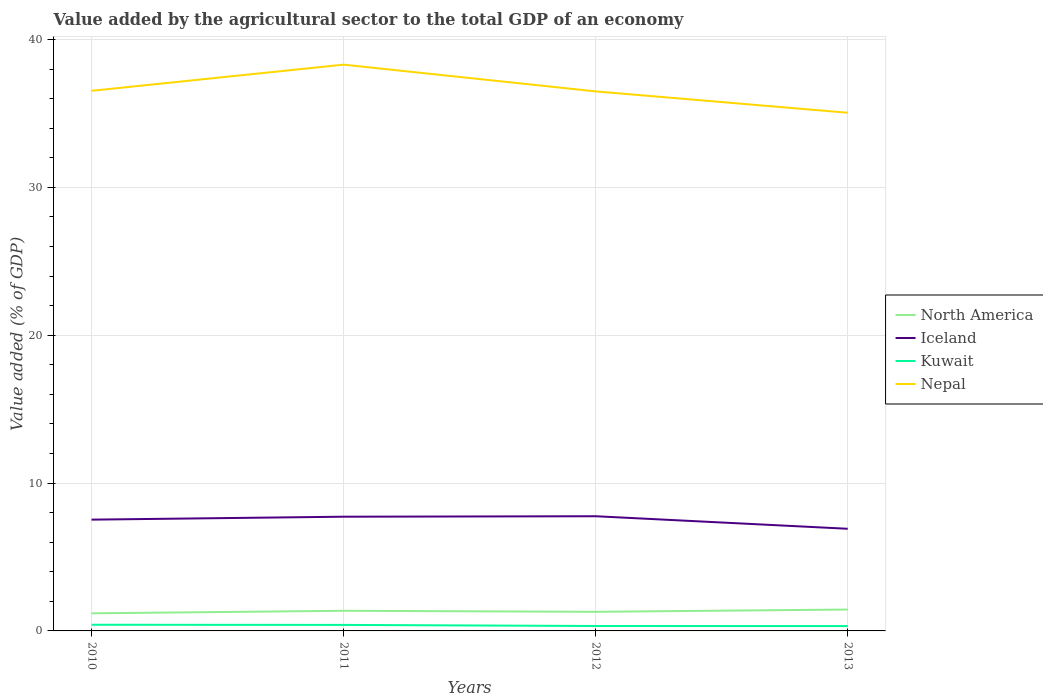How many different coloured lines are there?
Keep it short and to the point. 4. Does the line corresponding to Nepal intersect with the line corresponding to Kuwait?
Provide a short and direct response. No. Across all years, what is the maximum value added by the agricultural sector to the total GDP in North America?
Give a very brief answer. 1.19. What is the total value added by the agricultural sector to the total GDP in North America in the graph?
Provide a short and direct response. -0.08. What is the difference between the highest and the second highest value added by the agricultural sector to the total GDP in North America?
Offer a very short reply. 0.26. What is the difference between the highest and the lowest value added by the agricultural sector to the total GDP in North America?
Your answer should be very brief. 2. Is the value added by the agricultural sector to the total GDP in Nepal strictly greater than the value added by the agricultural sector to the total GDP in Iceland over the years?
Your answer should be very brief. No. How many lines are there?
Your answer should be compact. 4. What is the difference between two consecutive major ticks on the Y-axis?
Your response must be concise. 10. How are the legend labels stacked?
Provide a short and direct response. Vertical. What is the title of the graph?
Give a very brief answer. Value added by the agricultural sector to the total GDP of an economy. What is the label or title of the X-axis?
Your answer should be compact. Years. What is the label or title of the Y-axis?
Provide a short and direct response. Value added (% of GDP). What is the Value added (% of GDP) in North America in 2010?
Make the answer very short. 1.19. What is the Value added (% of GDP) of Iceland in 2010?
Your response must be concise. 7.53. What is the Value added (% of GDP) in Kuwait in 2010?
Ensure brevity in your answer.  0.42. What is the Value added (% of GDP) of Nepal in 2010?
Your response must be concise. 36.53. What is the Value added (% of GDP) of North America in 2011?
Keep it short and to the point. 1.36. What is the Value added (% of GDP) of Iceland in 2011?
Your answer should be very brief. 7.72. What is the Value added (% of GDP) in Kuwait in 2011?
Give a very brief answer. 0.41. What is the Value added (% of GDP) of Nepal in 2011?
Your answer should be compact. 38.3. What is the Value added (% of GDP) of North America in 2012?
Make the answer very short. 1.29. What is the Value added (% of GDP) in Iceland in 2012?
Provide a succinct answer. 7.76. What is the Value added (% of GDP) of Kuwait in 2012?
Your response must be concise. 0.33. What is the Value added (% of GDP) in Nepal in 2012?
Give a very brief answer. 36.49. What is the Value added (% of GDP) of North America in 2013?
Your response must be concise. 1.45. What is the Value added (% of GDP) in Iceland in 2013?
Your response must be concise. 6.91. What is the Value added (% of GDP) of Kuwait in 2013?
Make the answer very short. 0.33. What is the Value added (% of GDP) in Nepal in 2013?
Keep it short and to the point. 35.05. Across all years, what is the maximum Value added (% of GDP) of North America?
Your response must be concise. 1.45. Across all years, what is the maximum Value added (% of GDP) of Iceland?
Make the answer very short. 7.76. Across all years, what is the maximum Value added (% of GDP) of Kuwait?
Your response must be concise. 0.42. Across all years, what is the maximum Value added (% of GDP) of Nepal?
Offer a terse response. 38.3. Across all years, what is the minimum Value added (% of GDP) in North America?
Your response must be concise. 1.19. Across all years, what is the minimum Value added (% of GDP) in Iceland?
Keep it short and to the point. 6.91. Across all years, what is the minimum Value added (% of GDP) in Kuwait?
Offer a terse response. 0.33. Across all years, what is the minimum Value added (% of GDP) of Nepal?
Ensure brevity in your answer.  35.05. What is the total Value added (% of GDP) of North America in the graph?
Provide a succinct answer. 5.29. What is the total Value added (% of GDP) in Iceland in the graph?
Offer a very short reply. 29.91. What is the total Value added (% of GDP) in Kuwait in the graph?
Ensure brevity in your answer.  1.49. What is the total Value added (% of GDP) of Nepal in the graph?
Ensure brevity in your answer.  146.36. What is the difference between the Value added (% of GDP) in North America in 2010 and that in 2011?
Your answer should be very brief. -0.17. What is the difference between the Value added (% of GDP) of Iceland in 2010 and that in 2011?
Your answer should be very brief. -0.2. What is the difference between the Value added (% of GDP) in Kuwait in 2010 and that in 2011?
Your answer should be compact. 0.01. What is the difference between the Value added (% of GDP) in Nepal in 2010 and that in 2011?
Keep it short and to the point. -1.77. What is the difference between the Value added (% of GDP) in North America in 2010 and that in 2012?
Offer a terse response. -0.1. What is the difference between the Value added (% of GDP) of Iceland in 2010 and that in 2012?
Give a very brief answer. -0.23. What is the difference between the Value added (% of GDP) of Kuwait in 2010 and that in 2012?
Offer a very short reply. 0.09. What is the difference between the Value added (% of GDP) in Nepal in 2010 and that in 2012?
Provide a short and direct response. 0.04. What is the difference between the Value added (% of GDP) in North America in 2010 and that in 2013?
Your answer should be very brief. -0.26. What is the difference between the Value added (% of GDP) of Iceland in 2010 and that in 2013?
Offer a very short reply. 0.62. What is the difference between the Value added (% of GDP) of Kuwait in 2010 and that in 2013?
Your answer should be very brief. 0.09. What is the difference between the Value added (% of GDP) of Nepal in 2010 and that in 2013?
Offer a terse response. 1.48. What is the difference between the Value added (% of GDP) in North America in 2011 and that in 2012?
Offer a terse response. 0.07. What is the difference between the Value added (% of GDP) of Iceland in 2011 and that in 2012?
Make the answer very short. -0.03. What is the difference between the Value added (% of GDP) in Kuwait in 2011 and that in 2012?
Give a very brief answer. 0.07. What is the difference between the Value added (% of GDP) in Nepal in 2011 and that in 2012?
Ensure brevity in your answer.  1.81. What is the difference between the Value added (% of GDP) in North America in 2011 and that in 2013?
Make the answer very short. -0.08. What is the difference between the Value added (% of GDP) of Iceland in 2011 and that in 2013?
Ensure brevity in your answer.  0.82. What is the difference between the Value added (% of GDP) in Kuwait in 2011 and that in 2013?
Ensure brevity in your answer.  0.08. What is the difference between the Value added (% of GDP) in Nepal in 2011 and that in 2013?
Make the answer very short. 3.25. What is the difference between the Value added (% of GDP) of North America in 2012 and that in 2013?
Offer a terse response. -0.15. What is the difference between the Value added (% of GDP) of Iceland in 2012 and that in 2013?
Ensure brevity in your answer.  0.85. What is the difference between the Value added (% of GDP) in Kuwait in 2012 and that in 2013?
Your answer should be compact. 0. What is the difference between the Value added (% of GDP) of Nepal in 2012 and that in 2013?
Offer a terse response. 1.44. What is the difference between the Value added (% of GDP) of North America in 2010 and the Value added (% of GDP) of Iceland in 2011?
Provide a succinct answer. -6.53. What is the difference between the Value added (% of GDP) of North America in 2010 and the Value added (% of GDP) of Kuwait in 2011?
Provide a succinct answer. 0.78. What is the difference between the Value added (% of GDP) in North America in 2010 and the Value added (% of GDP) in Nepal in 2011?
Your response must be concise. -37.11. What is the difference between the Value added (% of GDP) in Iceland in 2010 and the Value added (% of GDP) in Kuwait in 2011?
Your response must be concise. 7.12. What is the difference between the Value added (% of GDP) of Iceland in 2010 and the Value added (% of GDP) of Nepal in 2011?
Your answer should be very brief. -30.77. What is the difference between the Value added (% of GDP) of Kuwait in 2010 and the Value added (% of GDP) of Nepal in 2011?
Give a very brief answer. -37.88. What is the difference between the Value added (% of GDP) in North America in 2010 and the Value added (% of GDP) in Iceland in 2012?
Give a very brief answer. -6.57. What is the difference between the Value added (% of GDP) in North America in 2010 and the Value added (% of GDP) in Kuwait in 2012?
Offer a very short reply. 0.86. What is the difference between the Value added (% of GDP) in North America in 2010 and the Value added (% of GDP) in Nepal in 2012?
Offer a very short reply. -35.3. What is the difference between the Value added (% of GDP) of Iceland in 2010 and the Value added (% of GDP) of Kuwait in 2012?
Offer a very short reply. 7.19. What is the difference between the Value added (% of GDP) of Iceland in 2010 and the Value added (% of GDP) of Nepal in 2012?
Your answer should be compact. -28.96. What is the difference between the Value added (% of GDP) in Kuwait in 2010 and the Value added (% of GDP) in Nepal in 2012?
Offer a very short reply. -36.07. What is the difference between the Value added (% of GDP) in North America in 2010 and the Value added (% of GDP) in Iceland in 2013?
Your answer should be very brief. -5.72. What is the difference between the Value added (% of GDP) in North America in 2010 and the Value added (% of GDP) in Kuwait in 2013?
Offer a very short reply. 0.86. What is the difference between the Value added (% of GDP) of North America in 2010 and the Value added (% of GDP) of Nepal in 2013?
Make the answer very short. -33.86. What is the difference between the Value added (% of GDP) of Iceland in 2010 and the Value added (% of GDP) of Kuwait in 2013?
Offer a very short reply. 7.2. What is the difference between the Value added (% of GDP) in Iceland in 2010 and the Value added (% of GDP) in Nepal in 2013?
Make the answer very short. -27.52. What is the difference between the Value added (% of GDP) of Kuwait in 2010 and the Value added (% of GDP) of Nepal in 2013?
Keep it short and to the point. -34.63. What is the difference between the Value added (% of GDP) of North America in 2011 and the Value added (% of GDP) of Iceland in 2012?
Keep it short and to the point. -6.39. What is the difference between the Value added (% of GDP) in North America in 2011 and the Value added (% of GDP) in Kuwait in 2012?
Give a very brief answer. 1.03. What is the difference between the Value added (% of GDP) in North America in 2011 and the Value added (% of GDP) in Nepal in 2012?
Your answer should be very brief. -35.13. What is the difference between the Value added (% of GDP) in Iceland in 2011 and the Value added (% of GDP) in Kuwait in 2012?
Keep it short and to the point. 7.39. What is the difference between the Value added (% of GDP) in Iceland in 2011 and the Value added (% of GDP) in Nepal in 2012?
Offer a terse response. -28.77. What is the difference between the Value added (% of GDP) in Kuwait in 2011 and the Value added (% of GDP) in Nepal in 2012?
Keep it short and to the point. -36.08. What is the difference between the Value added (% of GDP) of North America in 2011 and the Value added (% of GDP) of Iceland in 2013?
Your response must be concise. -5.55. What is the difference between the Value added (% of GDP) in North America in 2011 and the Value added (% of GDP) in Kuwait in 2013?
Offer a very short reply. 1.03. What is the difference between the Value added (% of GDP) in North America in 2011 and the Value added (% of GDP) in Nepal in 2013?
Make the answer very short. -33.68. What is the difference between the Value added (% of GDP) of Iceland in 2011 and the Value added (% of GDP) of Kuwait in 2013?
Provide a succinct answer. 7.39. What is the difference between the Value added (% of GDP) in Iceland in 2011 and the Value added (% of GDP) in Nepal in 2013?
Make the answer very short. -27.32. What is the difference between the Value added (% of GDP) in Kuwait in 2011 and the Value added (% of GDP) in Nepal in 2013?
Your answer should be very brief. -34.64. What is the difference between the Value added (% of GDP) of North America in 2012 and the Value added (% of GDP) of Iceland in 2013?
Offer a terse response. -5.62. What is the difference between the Value added (% of GDP) in North America in 2012 and the Value added (% of GDP) in Kuwait in 2013?
Provide a short and direct response. 0.96. What is the difference between the Value added (% of GDP) in North America in 2012 and the Value added (% of GDP) in Nepal in 2013?
Provide a succinct answer. -33.75. What is the difference between the Value added (% of GDP) of Iceland in 2012 and the Value added (% of GDP) of Kuwait in 2013?
Provide a succinct answer. 7.43. What is the difference between the Value added (% of GDP) of Iceland in 2012 and the Value added (% of GDP) of Nepal in 2013?
Offer a very short reply. -27.29. What is the difference between the Value added (% of GDP) in Kuwait in 2012 and the Value added (% of GDP) in Nepal in 2013?
Ensure brevity in your answer.  -34.71. What is the average Value added (% of GDP) in North America per year?
Provide a succinct answer. 1.32. What is the average Value added (% of GDP) of Iceland per year?
Ensure brevity in your answer.  7.48. What is the average Value added (% of GDP) in Kuwait per year?
Ensure brevity in your answer.  0.37. What is the average Value added (% of GDP) in Nepal per year?
Your answer should be compact. 36.59. In the year 2010, what is the difference between the Value added (% of GDP) of North America and Value added (% of GDP) of Iceland?
Your response must be concise. -6.34. In the year 2010, what is the difference between the Value added (% of GDP) of North America and Value added (% of GDP) of Kuwait?
Ensure brevity in your answer.  0.77. In the year 2010, what is the difference between the Value added (% of GDP) of North America and Value added (% of GDP) of Nepal?
Provide a succinct answer. -35.34. In the year 2010, what is the difference between the Value added (% of GDP) in Iceland and Value added (% of GDP) in Kuwait?
Offer a terse response. 7.11. In the year 2010, what is the difference between the Value added (% of GDP) in Iceland and Value added (% of GDP) in Nepal?
Offer a very short reply. -29. In the year 2010, what is the difference between the Value added (% of GDP) in Kuwait and Value added (% of GDP) in Nepal?
Provide a short and direct response. -36.11. In the year 2011, what is the difference between the Value added (% of GDP) in North America and Value added (% of GDP) in Iceland?
Provide a succinct answer. -6.36. In the year 2011, what is the difference between the Value added (% of GDP) of North America and Value added (% of GDP) of Kuwait?
Offer a terse response. 0.96. In the year 2011, what is the difference between the Value added (% of GDP) in North America and Value added (% of GDP) in Nepal?
Keep it short and to the point. -36.94. In the year 2011, what is the difference between the Value added (% of GDP) in Iceland and Value added (% of GDP) in Kuwait?
Your answer should be very brief. 7.32. In the year 2011, what is the difference between the Value added (% of GDP) of Iceland and Value added (% of GDP) of Nepal?
Your response must be concise. -30.57. In the year 2011, what is the difference between the Value added (% of GDP) of Kuwait and Value added (% of GDP) of Nepal?
Offer a terse response. -37.89. In the year 2012, what is the difference between the Value added (% of GDP) in North America and Value added (% of GDP) in Iceland?
Offer a terse response. -6.46. In the year 2012, what is the difference between the Value added (% of GDP) in North America and Value added (% of GDP) in Kuwait?
Offer a terse response. 0.96. In the year 2012, what is the difference between the Value added (% of GDP) of North America and Value added (% of GDP) of Nepal?
Your answer should be compact. -35.2. In the year 2012, what is the difference between the Value added (% of GDP) in Iceland and Value added (% of GDP) in Kuwait?
Ensure brevity in your answer.  7.42. In the year 2012, what is the difference between the Value added (% of GDP) in Iceland and Value added (% of GDP) in Nepal?
Provide a short and direct response. -28.73. In the year 2012, what is the difference between the Value added (% of GDP) in Kuwait and Value added (% of GDP) in Nepal?
Provide a succinct answer. -36.16. In the year 2013, what is the difference between the Value added (% of GDP) in North America and Value added (% of GDP) in Iceland?
Your answer should be very brief. -5.46. In the year 2013, what is the difference between the Value added (% of GDP) in North America and Value added (% of GDP) in Kuwait?
Your answer should be very brief. 1.12. In the year 2013, what is the difference between the Value added (% of GDP) of North America and Value added (% of GDP) of Nepal?
Offer a terse response. -33.6. In the year 2013, what is the difference between the Value added (% of GDP) in Iceland and Value added (% of GDP) in Kuwait?
Your response must be concise. 6.58. In the year 2013, what is the difference between the Value added (% of GDP) of Iceland and Value added (% of GDP) of Nepal?
Keep it short and to the point. -28.14. In the year 2013, what is the difference between the Value added (% of GDP) of Kuwait and Value added (% of GDP) of Nepal?
Your answer should be compact. -34.72. What is the ratio of the Value added (% of GDP) in North America in 2010 to that in 2011?
Keep it short and to the point. 0.87. What is the ratio of the Value added (% of GDP) in Iceland in 2010 to that in 2011?
Your response must be concise. 0.97. What is the ratio of the Value added (% of GDP) of Kuwait in 2010 to that in 2011?
Your answer should be very brief. 1.03. What is the ratio of the Value added (% of GDP) of Nepal in 2010 to that in 2011?
Offer a terse response. 0.95. What is the ratio of the Value added (% of GDP) of North America in 2010 to that in 2012?
Offer a terse response. 0.92. What is the ratio of the Value added (% of GDP) in Iceland in 2010 to that in 2012?
Make the answer very short. 0.97. What is the ratio of the Value added (% of GDP) in Kuwait in 2010 to that in 2012?
Keep it short and to the point. 1.26. What is the ratio of the Value added (% of GDP) in Nepal in 2010 to that in 2012?
Your answer should be very brief. 1. What is the ratio of the Value added (% of GDP) of North America in 2010 to that in 2013?
Keep it short and to the point. 0.82. What is the ratio of the Value added (% of GDP) in Iceland in 2010 to that in 2013?
Offer a terse response. 1.09. What is the ratio of the Value added (% of GDP) in Kuwait in 2010 to that in 2013?
Make the answer very short. 1.26. What is the ratio of the Value added (% of GDP) of Nepal in 2010 to that in 2013?
Give a very brief answer. 1.04. What is the ratio of the Value added (% of GDP) of North America in 2011 to that in 2012?
Your answer should be compact. 1.05. What is the ratio of the Value added (% of GDP) of Iceland in 2011 to that in 2012?
Your answer should be very brief. 1. What is the ratio of the Value added (% of GDP) in Kuwait in 2011 to that in 2012?
Give a very brief answer. 1.22. What is the ratio of the Value added (% of GDP) of Nepal in 2011 to that in 2012?
Provide a succinct answer. 1.05. What is the ratio of the Value added (% of GDP) in North America in 2011 to that in 2013?
Offer a terse response. 0.94. What is the ratio of the Value added (% of GDP) of Iceland in 2011 to that in 2013?
Ensure brevity in your answer.  1.12. What is the ratio of the Value added (% of GDP) of Kuwait in 2011 to that in 2013?
Your answer should be compact. 1.23. What is the ratio of the Value added (% of GDP) of Nepal in 2011 to that in 2013?
Your response must be concise. 1.09. What is the ratio of the Value added (% of GDP) of North America in 2012 to that in 2013?
Provide a succinct answer. 0.89. What is the ratio of the Value added (% of GDP) in Iceland in 2012 to that in 2013?
Keep it short and to the point. 1.12. What is the ratio of the Value added (% of GDP) of Nepal in 2012 to that in 2013?
Provide a short and direct response. 1.04. What is the difference between the highest and the second highest Value added (% of GDP) in North America?
Provide a short and direct response. 0.08. What is the difference between the highest and the second highest Value added (% of GDP) in Iceland?
Give a very brief answer. 0.03. What is the difference between the highest and the second highest Value added (% of GDP) of Kuwait?
Give a very brief answer. 0.01. What is the difference between the highest and the second highest Value added (% of GDP) of Nepal?
Give a very brief answer. 1.77. What is the difference between the highest and the lowest Value added (% of GDP) of North America?
Keep it short and to the point. 0.26. What is the difference between the highest and the lowest Value added (% of GDP) in Iceland?
Ensure brevity in your answer.  0.85. What is the difference between the highest and the lowest Value added (% of GDP) of Kuwait?
Provide a succinct answer. 0.09. What is the difference between the highest and the lowest Value added (% of GDP) of Nepal?
Offer a very short reply. 3.25. 